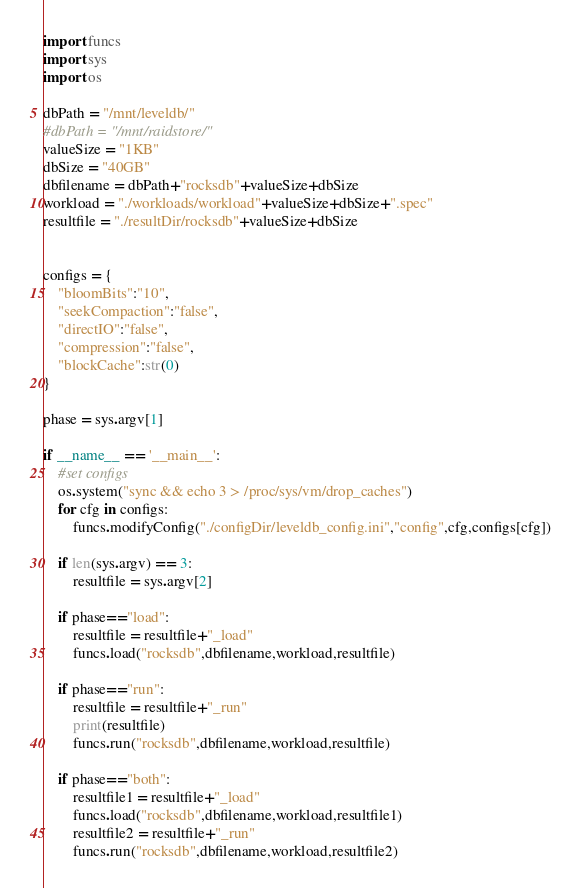Convert code to text. <code><loc_0><loc_0><loc_500><loc_500><_Python_>import funcs
import sys
import os

dbPath = "/mnt/leveldb/"
#dbPath = "/mnt/raidstore/"
valueSize = "1KB"
dbSize = "40GB"
dbfilename = dbPath+"rocksdb"+valueSize+dbSize
workload = "./workloads/workload"+valueSize+dbSize+".spec"
resultfile = "./resultDir/rocksdb"+valueSize+dbSize


configs = {
    "bloomBits":"10",
    "seekCompaction":"false",
    "directIO":"false",
    "compression":"false",
    "blockCache":str(0)
}

phase = sys.argv[1]

if __name__ == '__main__':
    #set configs
    os.system("sync && echo 3 > /proc/sys/vm/drop_caches")
    for cfg in configs:
        funcs.modifyConfig("./configDir/leveldb_config.ini","config",cfg,configs[cfg])

    if len(sys.argv) == 3:
        resultfile = sys.argv[2]

    if phase=="load":
        resultfile = resultfile+"_load"
        funcs.load("rocksdb",dbfilename,workload,resultfile)

    if phase=="run":
        resultfile = resultfile+"_run"
        print(resultfile)
        funcs.run("rocksdb",dbfilename,workload,resultfile)

    if phase=="both":
        resultfile1 = resultfile+"_load"
        funcs.load("rocksdb",dbfilename,workload,resultfile1)
        resultfile2 = resultfile+"_run"
        funcs.run("rocksdb",dbfilename,workload,resultfile2)
</code> 